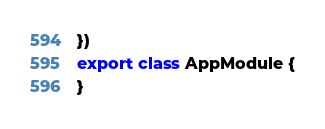<code> <loc_0><loc_0><loc_500><loc_500><_TypeScript_>})
export class AppModule {
}
</code> 